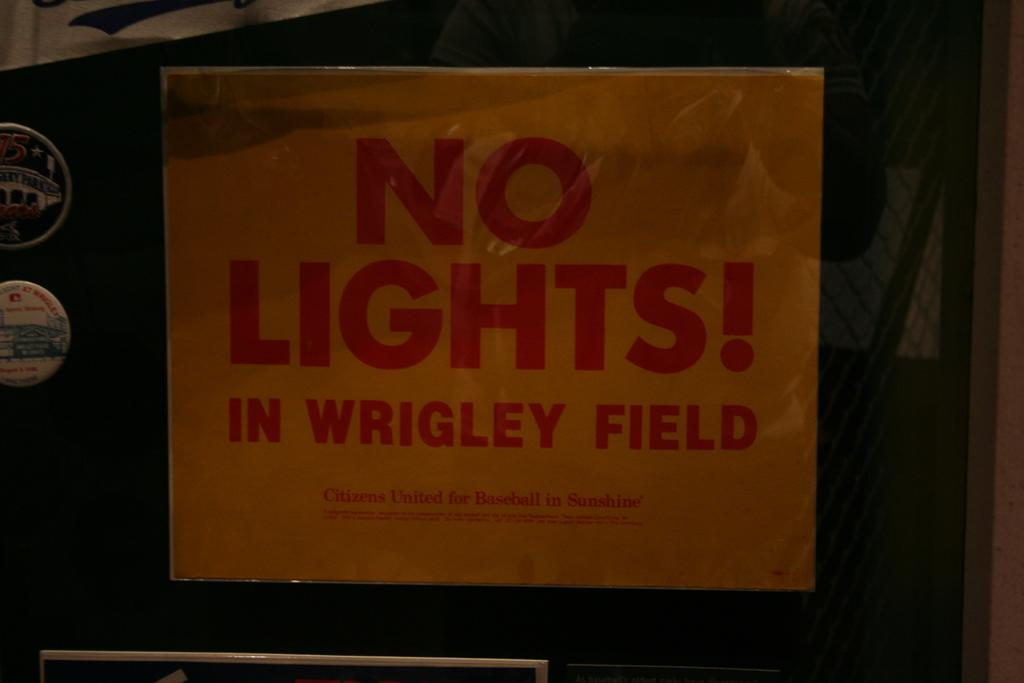<image>
Share a concise interpretation of the image provided. a sign that says no lights on it 